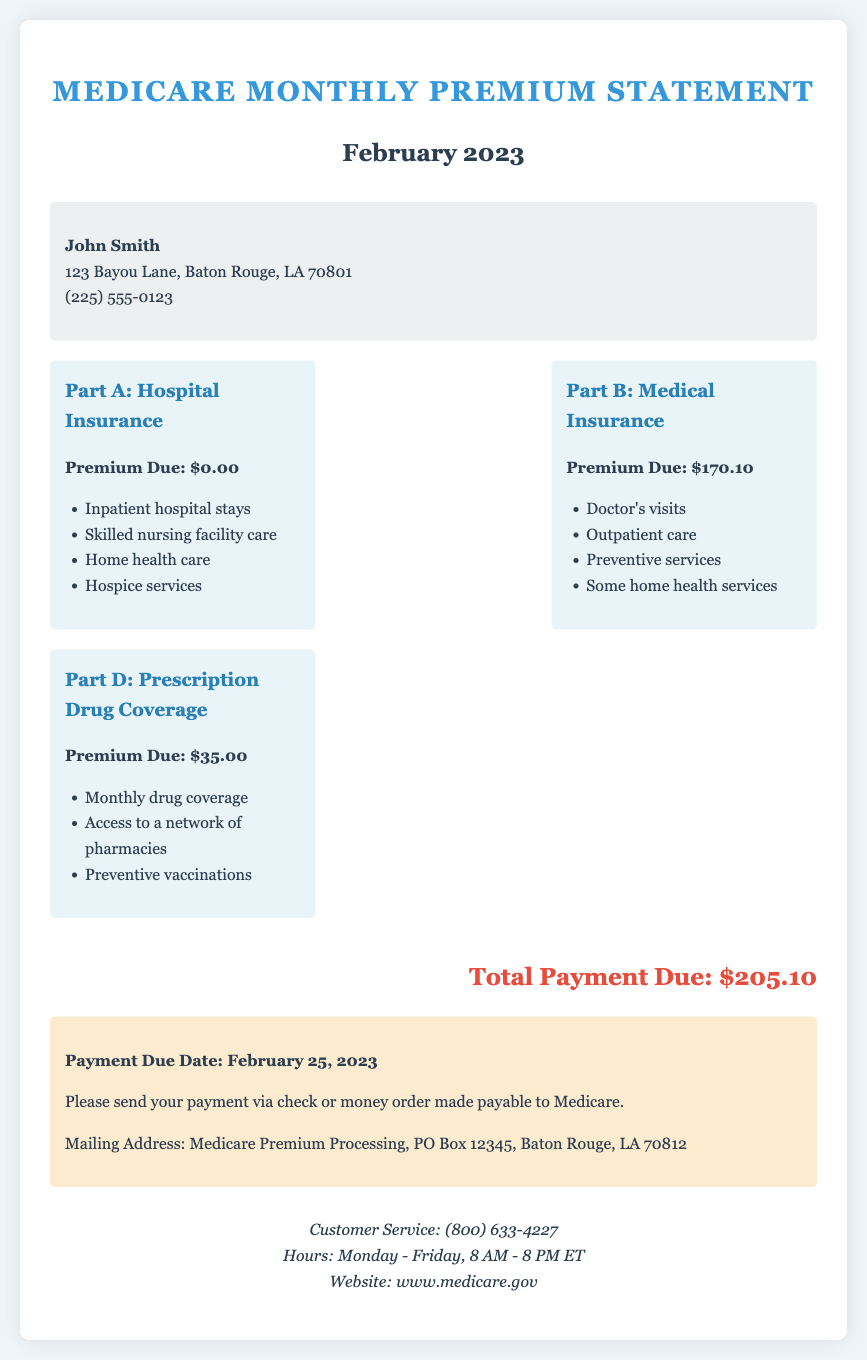What is the total payment due? The total payment due is clearly stated in the document as $205.10.
Answer: $205.10 What is the premium due for Part B? The document specifies that the premium due for Part B: Medical Insurance is $170.10.
Answer: $170.10 Who is the recipient of this statement? The recipient of the statement is mentioned at the top, as John Smith.
Answer: John Smith What is the payment due date? The payment due date is indicated in the payment information section as February 25, 2023.
Answer: February 25, 2023 What services are covered under Part A? The document lists several services under Part A, including inpatient hospital stays and hospice services.
Answer: Inpatient hospital stays, Skilled nursing facility care, Home health care, Hospice services What should the payment be made out to? The document instructs payments to be made payable to Medicare.
Answer: Medicare What is the customer service phone number? The document lists the customer service phone number as (800) 633-4227.
Answer: (800) 633-4227 What is included in Part D coverage? The document includes monthly drug coverage and access to a network of pharmacies under Part D.
Answer: Monthly drug coverage, Access to a network of pharmacies, Preventive vaccinations 